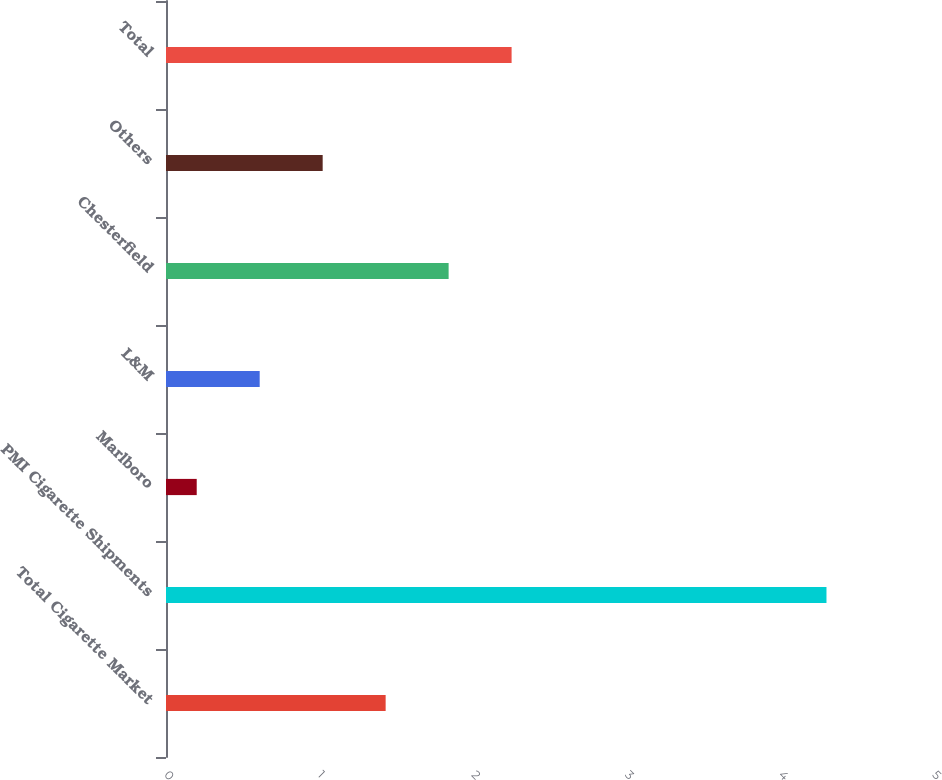Convert chart. <chart><loc_0><loc_0><loc_500><loc_500><bar_chart><fcel>Total Cigarette Market<fcel>PMI Cigarette Shipments<fcel>Marlboro<fcel>L&M<fcel>Chesterfield<fcel>Others<fcel>Total<nl><fcel>1.43<fcel>4.3<fcel>0.2<fcel>0.61<fcel>1.84<fcel>1.02<fcel>2.25<nl></chart> 